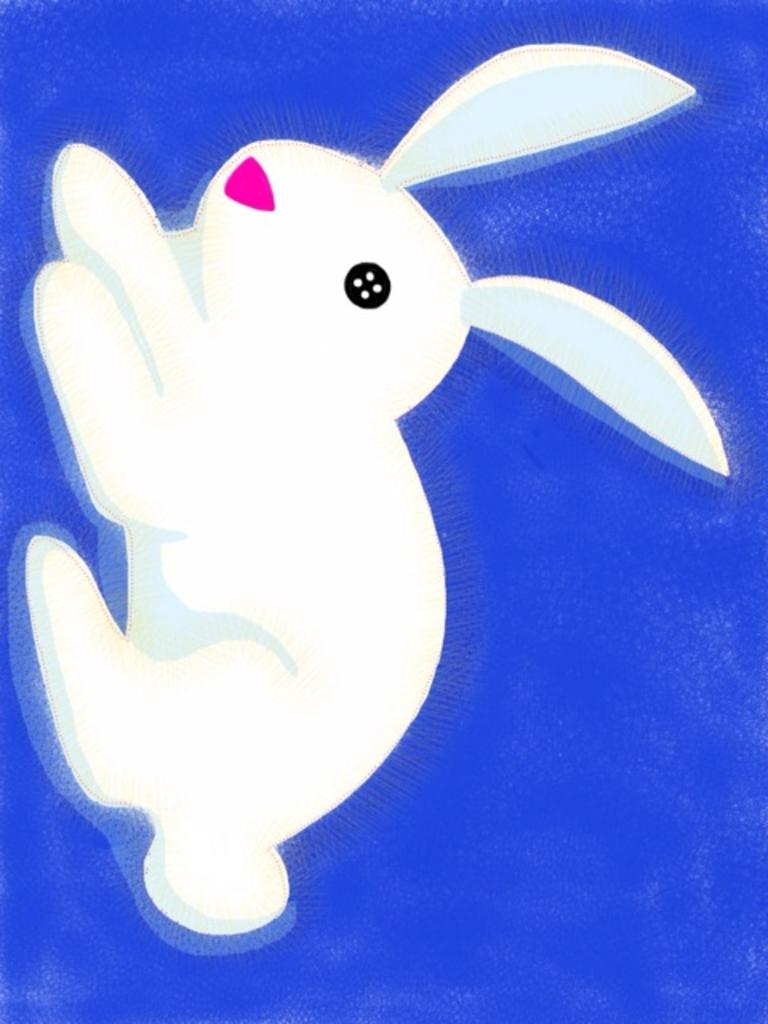What type of artwork is depicted in the image? The image is a painting. What animal can be seen in the painting? There is a rabbit in the painting. What color is the background of the painting? The background of the painting is blue. Where is the mailbox located in the painting? There is no mailbox present in the painting; it features a rabbit and a blue background. What type of event is taking place in the painting? There is no event depicted in the painting; it simply shows a rabbit in a blue environment. 